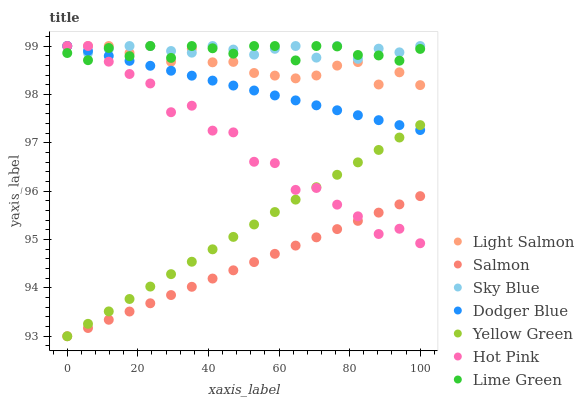Does Salmon have the minimum area under the curve?
Answer yes or no. Yes. Does Sky Blue have the maximum area under the curve?
Answer yes or no. Yes. Does Yellow Green have the minimum area under the curve?
Answer yes or no. No. Does Yellow Green have the maximum area under the curve?
Answer yes or no. No. Is Dodger Blue the smoothest?
Answer yes or no. Yes. Is Hot Pink the roughest?
Answer yes or no. Yes. Is Yellow Green the smoothest?
Answer yes or no. No. Is Yellow Green the roughest?
Answer yes or no. No. Does Yellow Green have the lowest value?
Answer yes or no. Yes. Does Hot Pink have the lowest value?
Answer yes or no. No. Does Lime Green have the highest value?
Answer yes or no. Yes. Does Yellow Green have the highest value?
Answer yes or no. No. Is Yellow Green less than Sky Blue?
Answer yes or no. Yes. Is Lime Green greater than Yellow Green?
Answer yes or no. Yes. Does Hot Pink intersect Dodger Blue?
Answer yes or no. Yes. Is Hot Pink less than Dodger Blue?
Answer yes or no. No. Is Hot Pink greater than Dodger Blue?
Answer yes or no. No. Does Yellow Green intersect Sky Blue?
Answer yes or no. No. 